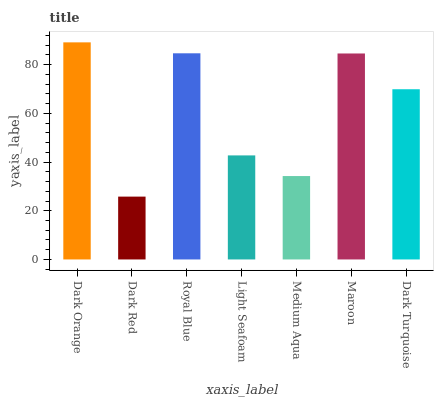Is Dark Red the minimum?
Answer yes or no. Yes. Is Dark Orange the maximum?
Answer yes or no. Yes. Is Royal Blue the minimum?
Answer yes or no. No. Is Royal Blue the maximum?
Answer yes or no. No. Is Royal Blue greater than Dark Red?
Answer yes or no. Yes. Is Dark Red less than Royal Blue?
Answer yes or no. Yes. Is Dark Red greater than Royal Blue?
Answer yes or no. No. Is Royal Blue less than Dark Red?
Answer yes or no. No. Is Dark Turquoise the high median?
Answer yes or no. Yes. Is Dark Turquoise the low median?
Answer yes or no. Yes. Is Light Seafoam the high median?
Answer yes or no. No. Is Medium Aqua the low median?
Answer yes or no. No. 